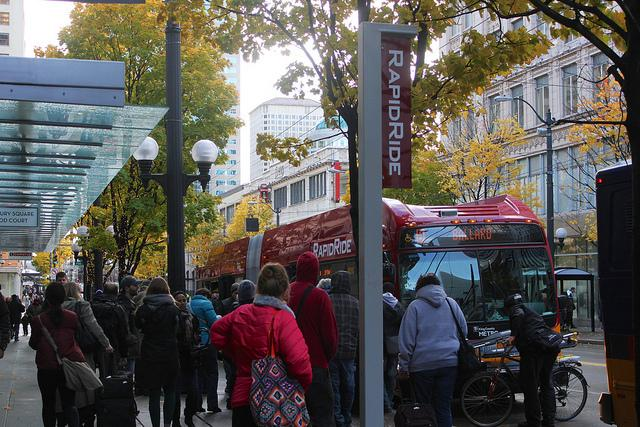Who are the people gathering there? Please explain your reasoning. tourists. They are in a city with lots of bags 